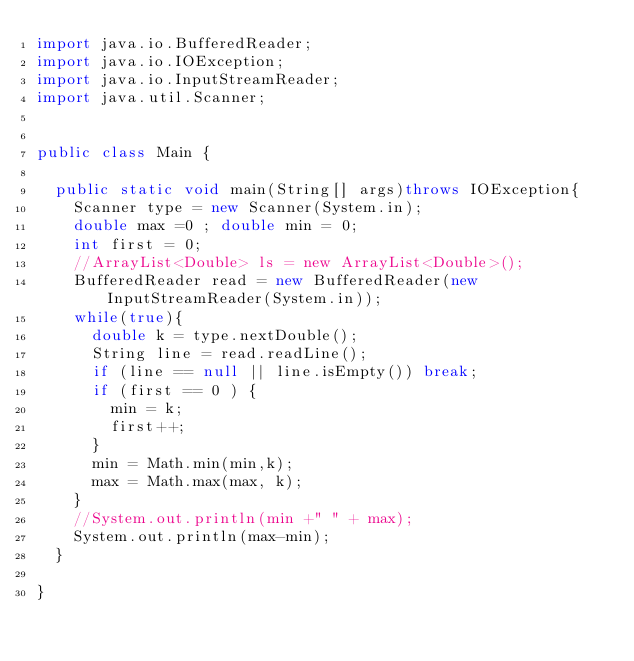Convert code to text. <code><loc_0><loc_0><loc_500><loc_500><_Java_>import java.io.BufferedReader;
import java.io.IOException;
import java.io.InputStreamReader;
import java.util.Scanner;


public class Main {

	public static void main(String[] args)throws IOException{
		Scanner type = new Scanner(System.in);
		double max =0 ; double min = 0;
		int first = 0;
		//ArrayList<Double> ls = new ArrayList<Double>();
		BufferedReader read = new BufferedReader(new InputStreamReader(System.in));
		while(true){
			double k = type.nextDouble();
			String line = read.readLine();
			if (line == null || line.isEmpty()) break;
			if (first == 0 ) {
				min = k;
				first++;
			}
			min = Math.min(min,k);
			max = Math.max(max, k);
		}
		//System.out.println(min +" " + max);
		System.out.println(max-min);
	}

}</code> 